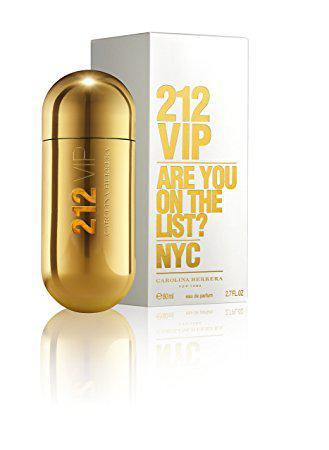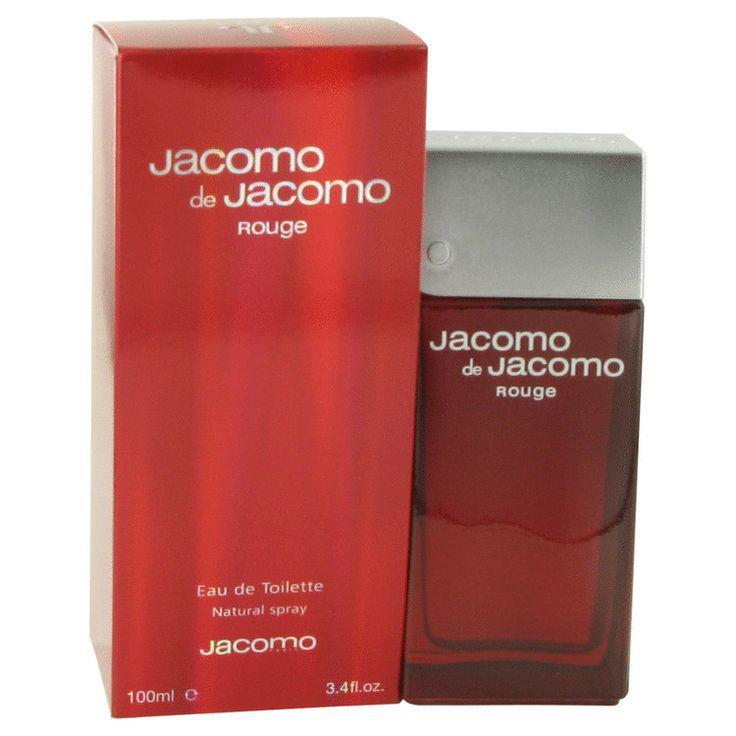The first image is the image on the left, the second image is the image on the right. For the images displayed, is the sentence "At least one image shows an upright capsule-shaped item next to its box." factually correct? Answer yes or no. Yes. The first image is the image on the left, the second image is the image on the right. Evaluate the accuracy of this statement regarding the images: "The perfume in the image on the left is capsule in shape.". Is it true? Answer yes or no. Yes. 